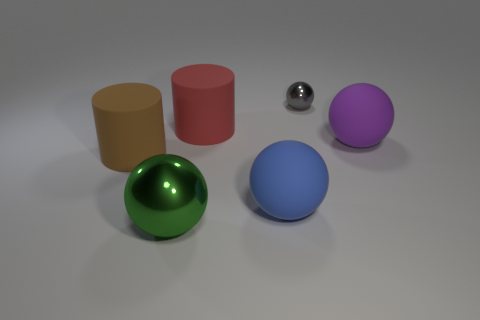Subtract all big balls. How many balls are left? 1 Subtract all gray balls. How many balls are left? 3 Add 1 brown things. How many objects exist? 7 Subtract 2 balls. How many balls are left? 2 Subtract all red spheres. Subtract all yellow cylinders. How many spheres are left? 4 Subtract all spheres. How many objects are left? 2 Subtract all cyan rubber things. Subtract all red objects. How many objects are left? 5 Add 5 purple things. How many purple things are left? 6 Add 6 green objects. How many green objects exist? 7 Subtract 1 red cylinders. How many objects are left? 5 